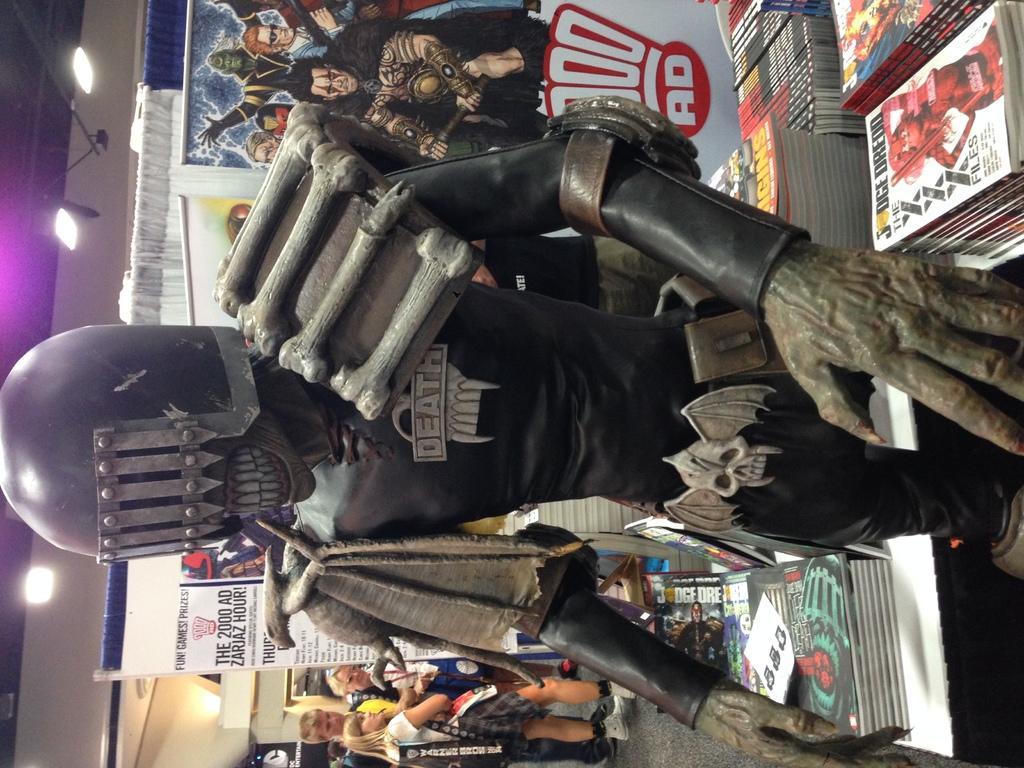Can you describe this image briefly? In this image we can see a statue. We can also see a group of books placed on the surface, some banners with text and pictures on them, a curtain, a group of people standing on the floor, a wall and a roof with some lights. 